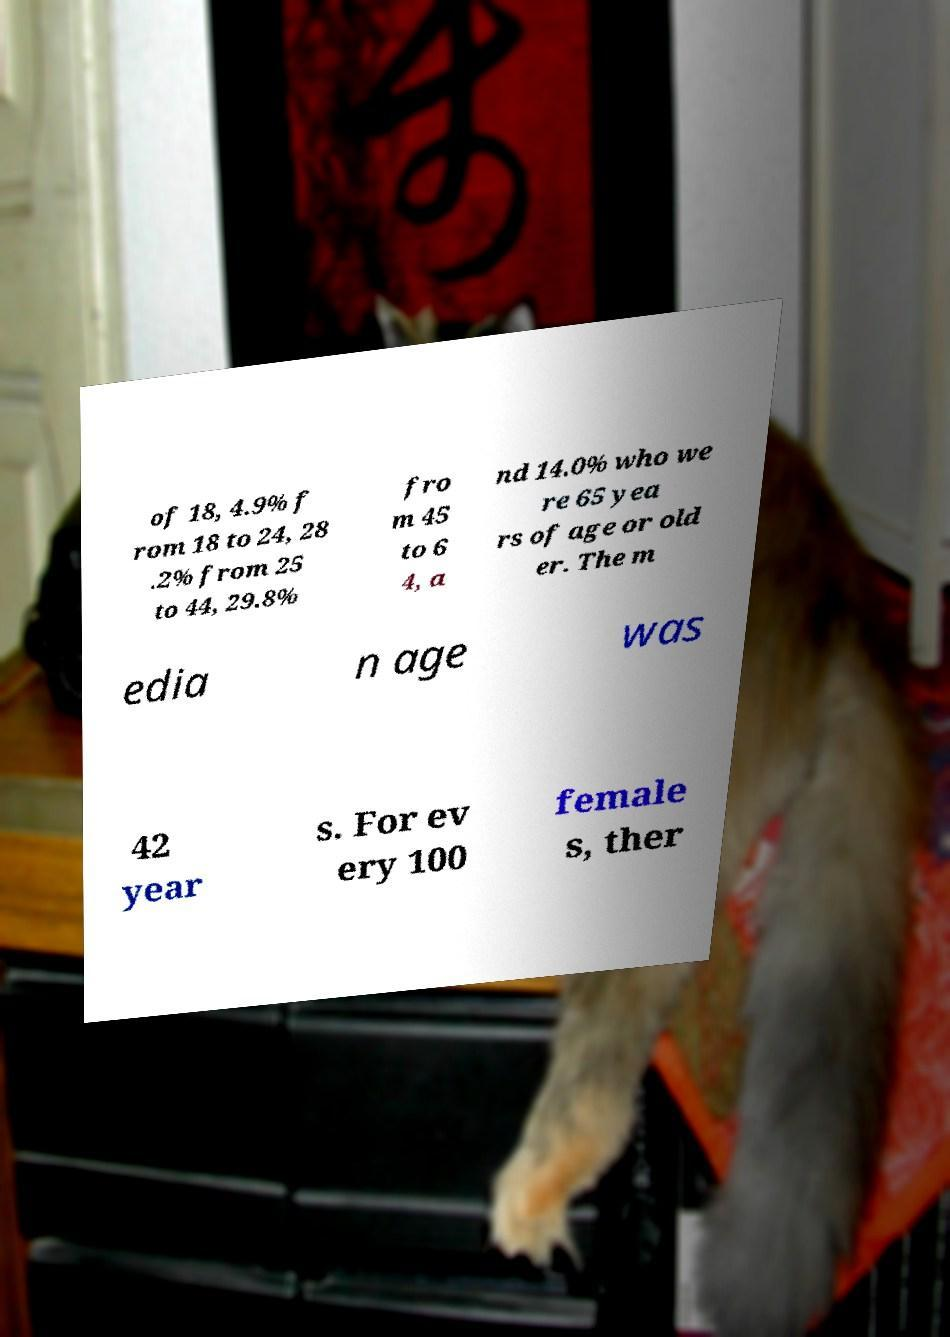Could you extract and type out the text from this image? of 18, 4.9% f rom 18 to 24, 28 .2% from 25 to 44, 29.8% fro m 45 to 6 4, a nd 14.0% who we re 65 yea rs of age or old er. The m edia n age was 42 year s. For ev ery 100 female s, ther 